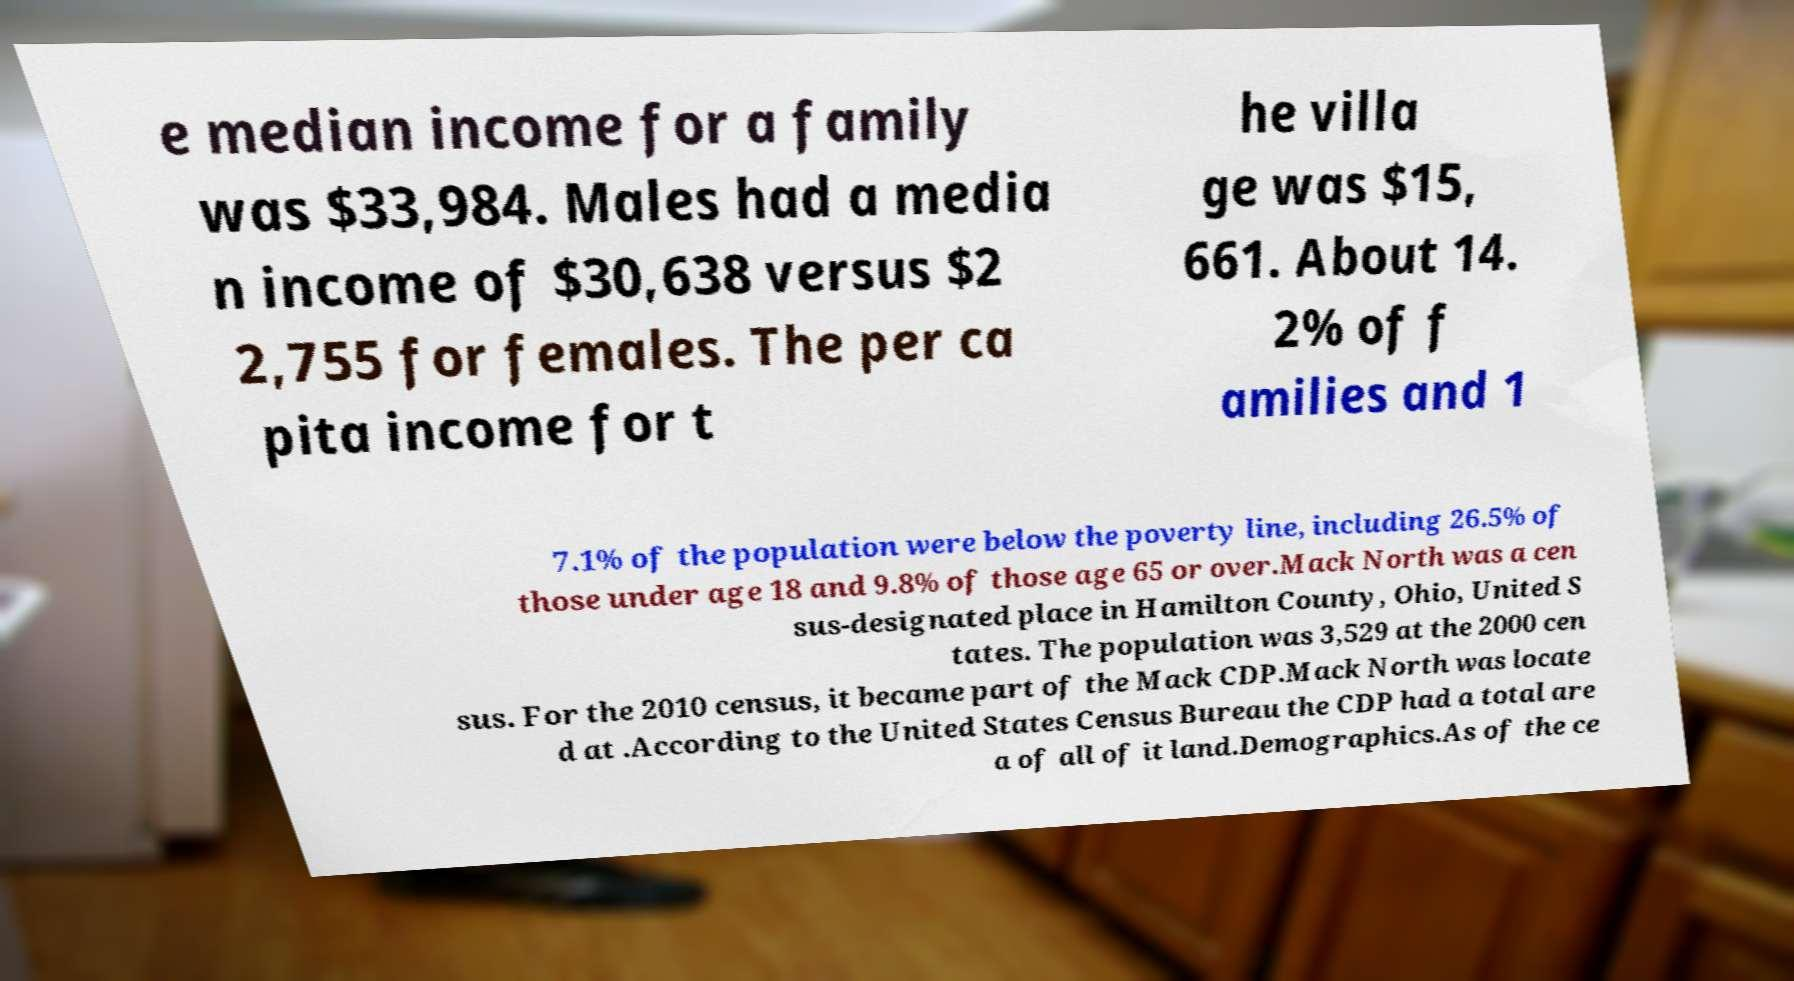Can you accurately transcribe the text from the provided image for me? e median income for a family was $33,984. Males had a media n income of $30,638 versus $2 2,755 for females. The per ca pita income for t he villa ge was $15, 661. About 14. 2% of f amilies and 1 7.1% of the population were below the poverty line, including 26.5% of those under age 18 and 9.8% of those age 65 or over.Mack North was a cen sus-designated place in Hamilton County, Ohio, United S tates. The population was 3,529 at the 2000 cen sus. For the 2010 census, it became part of the Mack CDP.Mack North was locate d at .According to the United States Census Bureau the CDP had a total are a of all of it land.Demographics.As of the ce 